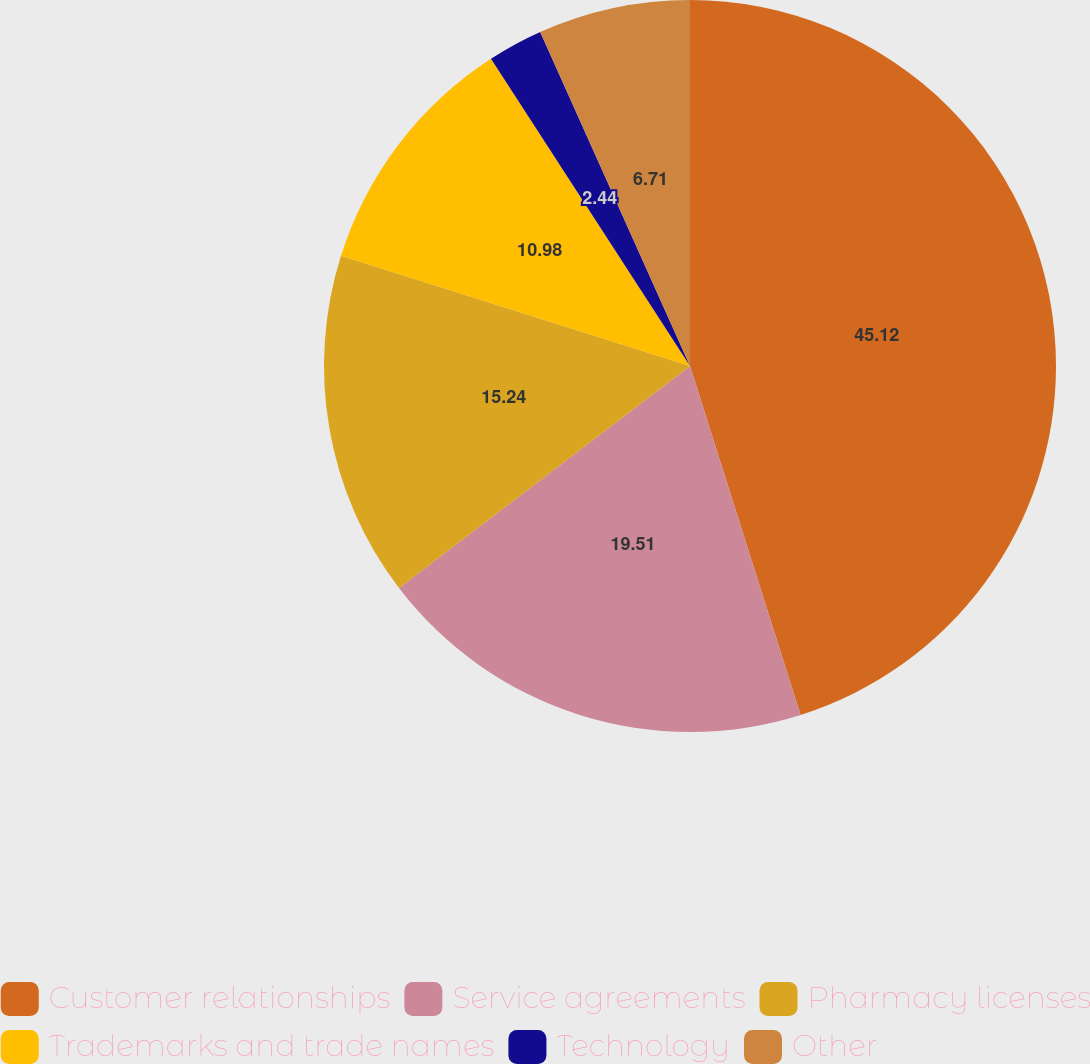<chart> <loc_0><loc_0><loc_500><loc_500><pie_chart><fcel>Customer relationships<fcel>Service agreements<fcel>Pharmacy licenses<fcel>Trademarks and trade names<fcel>Technology<fcel>Other<nl><fcel>45.11%<fcel>19.51%<fcel>15.24%<fcel>10.98%<fcel>2.44%<fcel>6.71%<nl></chart> 